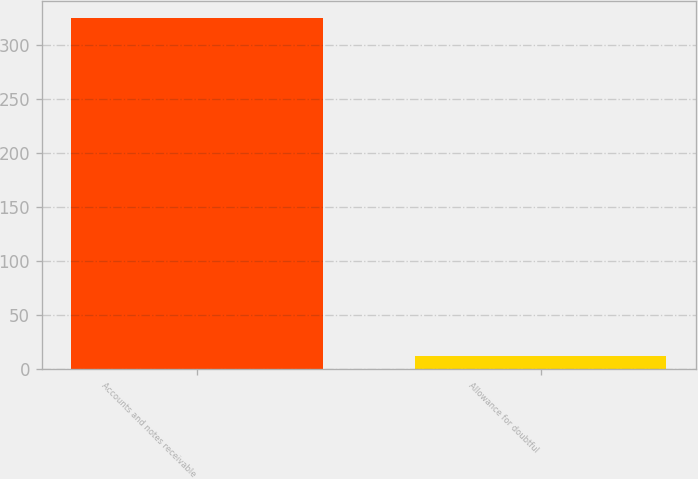<chart> <loc_0><loc_0><loc_500><loc_500><bar_chart><fcel>Accounts and notes receivable<fcel>Allowance for doubtful<nl><fcel>325<fcel>12<nl></chart> 